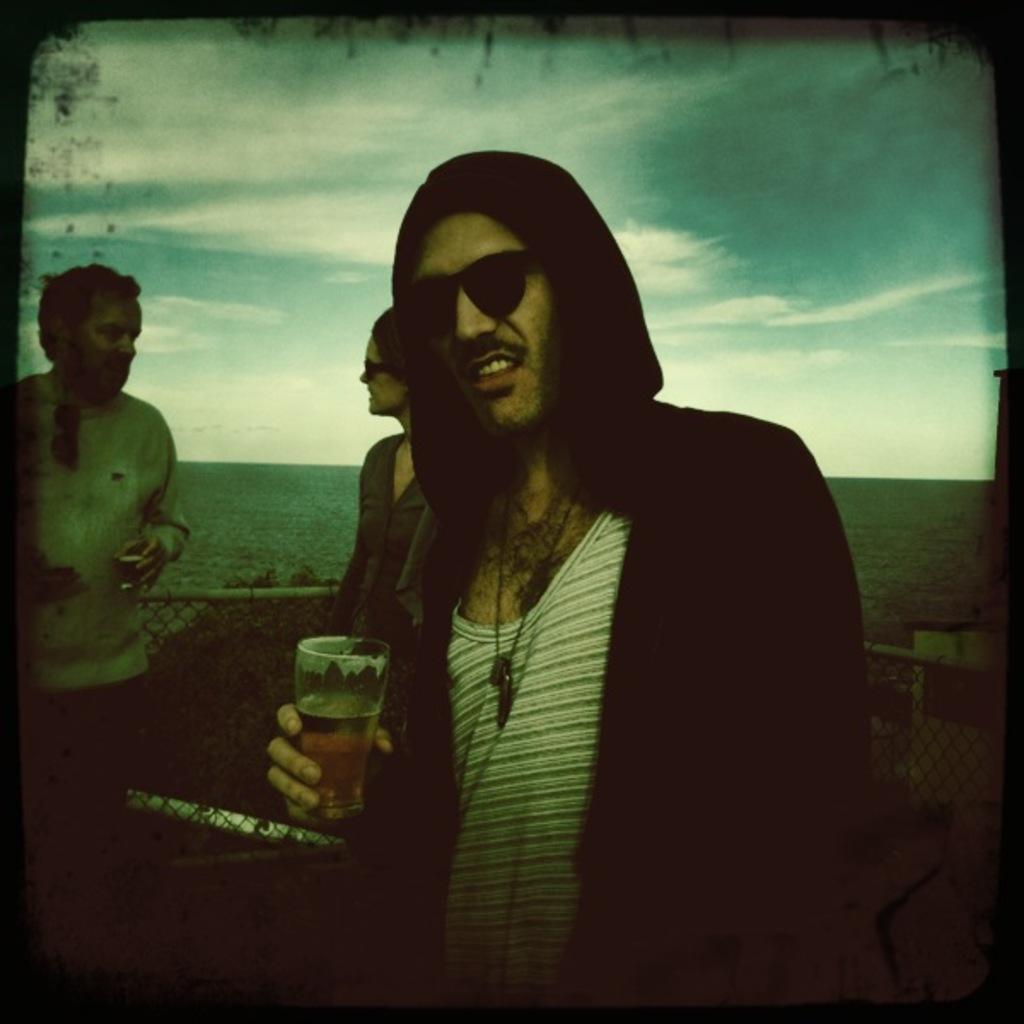Describe this image in one or two sentences. In this image, we can see three people. Few are holding glasses with liquid and wearing goggles. Here we can see mesh, rods. Background we can see the sea and sky. It is an edited picture. Borders we can see black color. 